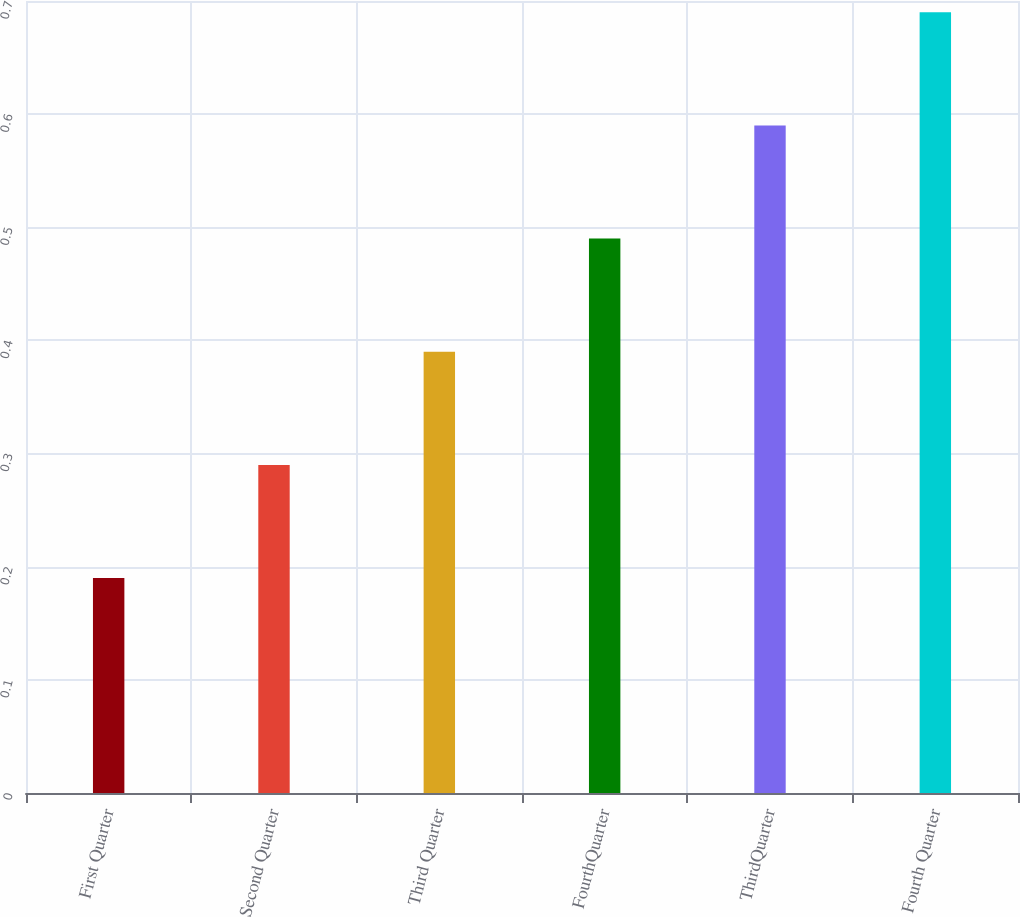<chart> <loc_0><loc_0><loc_500><loc_500><bar_chart><fcel>First Quarter<fcel>Second Quarter<fcel>Third Quarter<fcel>FourthQuarter<fcel>ThirdQuarter<fcel>Fourth Quarter<nl><fcel>0.19<fcel>0.29<fcel>0.39<fcel>0.49<fcel>0.59<fcel>0.69<nl></chart> 